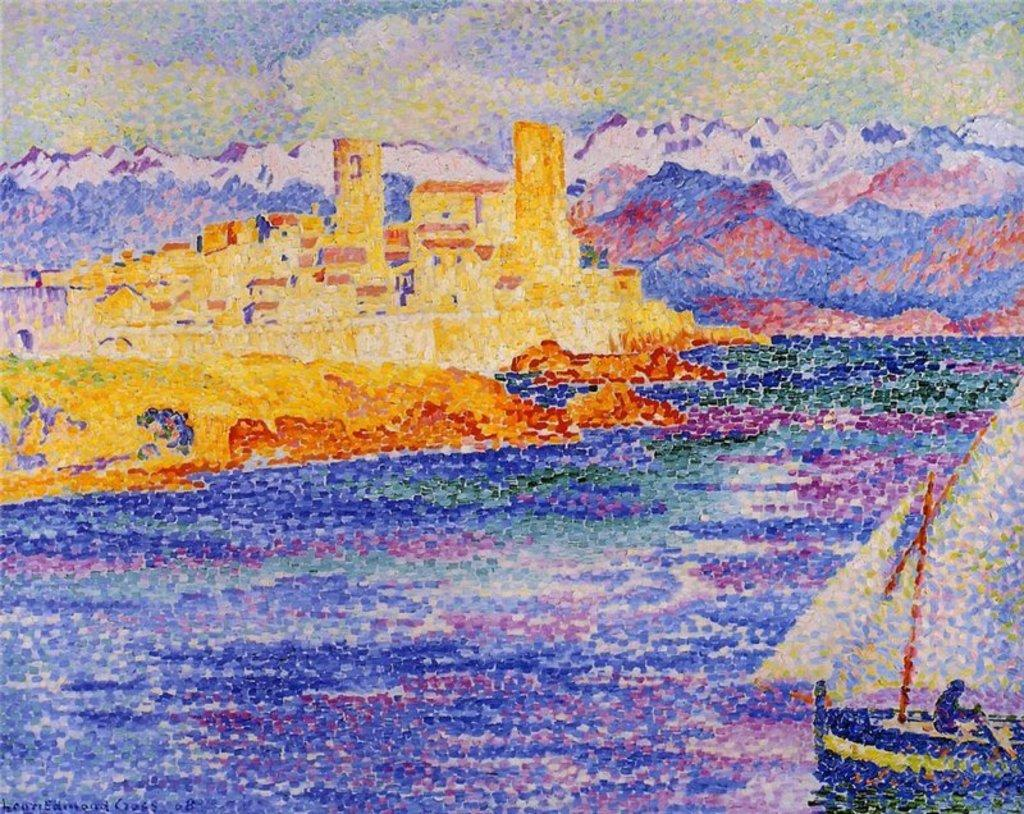What is the main subject of the image? There is a painting in the image. What natural element is visible in the image? There is water visible in the image. What mode of transportation can be seen in the water? There is a boat in the image. Who is present in the boat? There is a person sitting in the boat. What type of structures are visible in the image? There are buildings in the image. What geographical feature is visible in the background? There are mountains in the image. What part of the natural environment is visible in the image? The sky is visible in the image. What type of camera is the wren using to take a picture in the image? There is no wren or camera present in the image. 